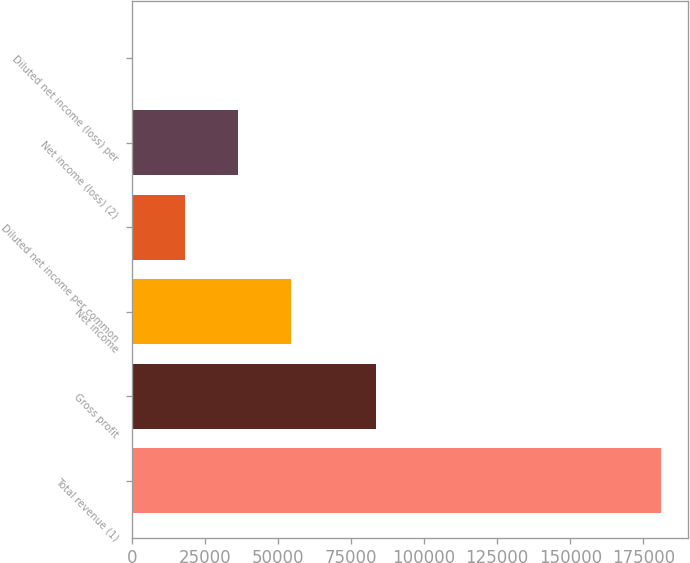Convert chart. <chart><loc_0><loc_0><loc_500><loc_500><bar_chart><fcel>Total revenue (1)<fcel>Gross profit<fcel>Net income<fcel>Diluted net income per common<fcel>Net income (loss) (2)<fcel>Diluted net income (loss) per<nl><fcel>181086<fcel>83548<fcel>54326<fcel>18108.8<fcel>36217.4<fcel>0.24<nl></chart> 